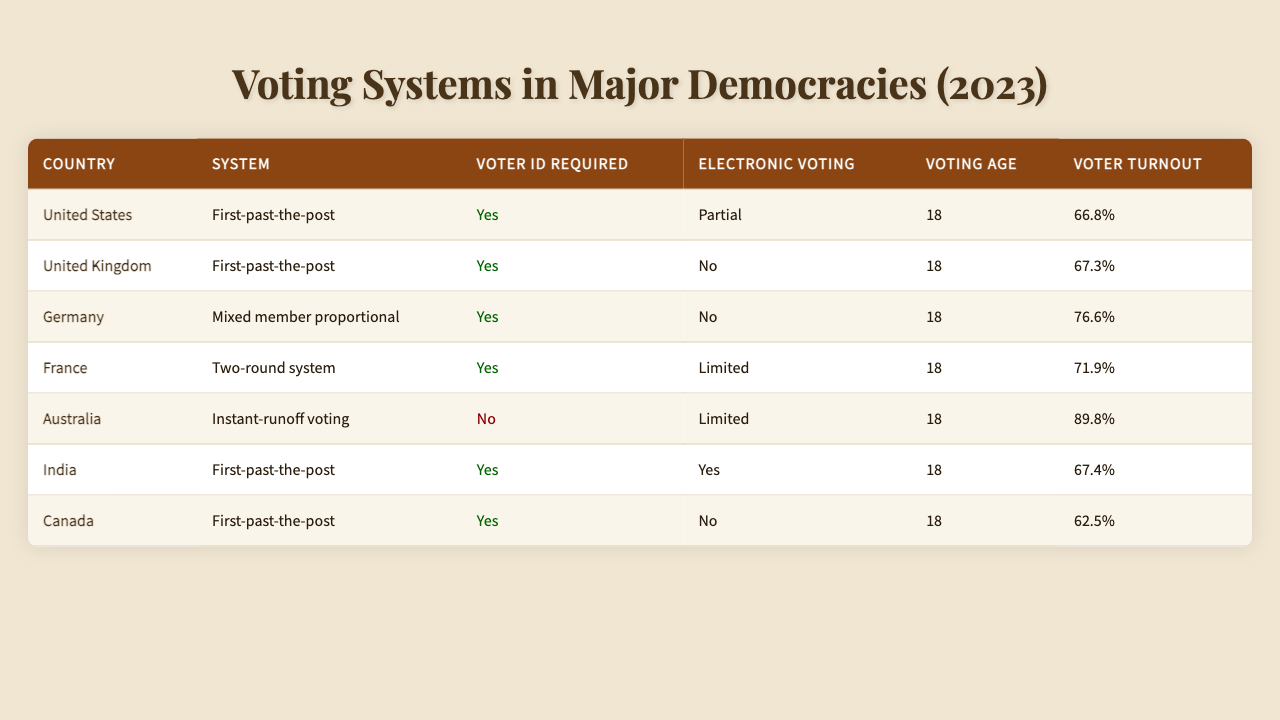What voting system is used in Germany? According to the table, Germany uses a "Mixed member proportional" voting system.
Answer: Mixed member proportional Which countries require voter ID? By checking the entries, it is noted that the United States, United Kingdom, Germany, France, India, and Canada all require voter ID.
Answer: 6 countries What is the voter turnout in Australia for the 2022 election? The table specifies that Australia's voter turnout in 2022 was "89.8%."
Answer: 89.8% Does the United Kingdom allow electronic voting? According to the table, the United Kingdom does not allow electronic voting, as indicated by "No."
Answer: No Which country had the highest voter turnout, and what was the percentage? The table shows that Australia had the highest voter turnout of "89.8%" in 2022, which is greater than other listed countries.
Answer: Australia, 89.8% What is the average voter turnout percentage from the countries listed? To find the average, sum the voter turnout percentages: (66.8 + 67.3 + 76.6 + 71.9 + 89.8 + 67.4 + 62.5) = 502.3. There are 7 entries, so the average is 502.3/7 ≈ 71.7%.
Answer: Approximately 71.7% Given that both the United States and India have a first-past-the-post system, can we say they have similar voting systems? Both countries do use a first-past-the-post voting system; thus, they are similar in that aspect despite potential differences in implementation.
Answer: Yes Which democratic country has the lowest voter turnout and what is that percentage? The table indicates that Canada has the lowest voter turnout at "62.5%" in the 2021 election.
Answer: Canada, 62.5% Is electronic voting completely allowed in any of the countries listed? Upon reviewing the table, only India allows electronic voting fully, while others have limitations or none at all.
Answer: Yes, India How many countries allow limited electronic voting? Referring to the table, France and Australia both allow limited electronic voting, totaling two countries.
Answer: 2 countries Which countries have the same voting age, and what is that age? All listed countries—United States, United Kingdom, Germany, France, Australia, India, and Canada—have a voting age of 18.
Answer: 7 countries, age 18 